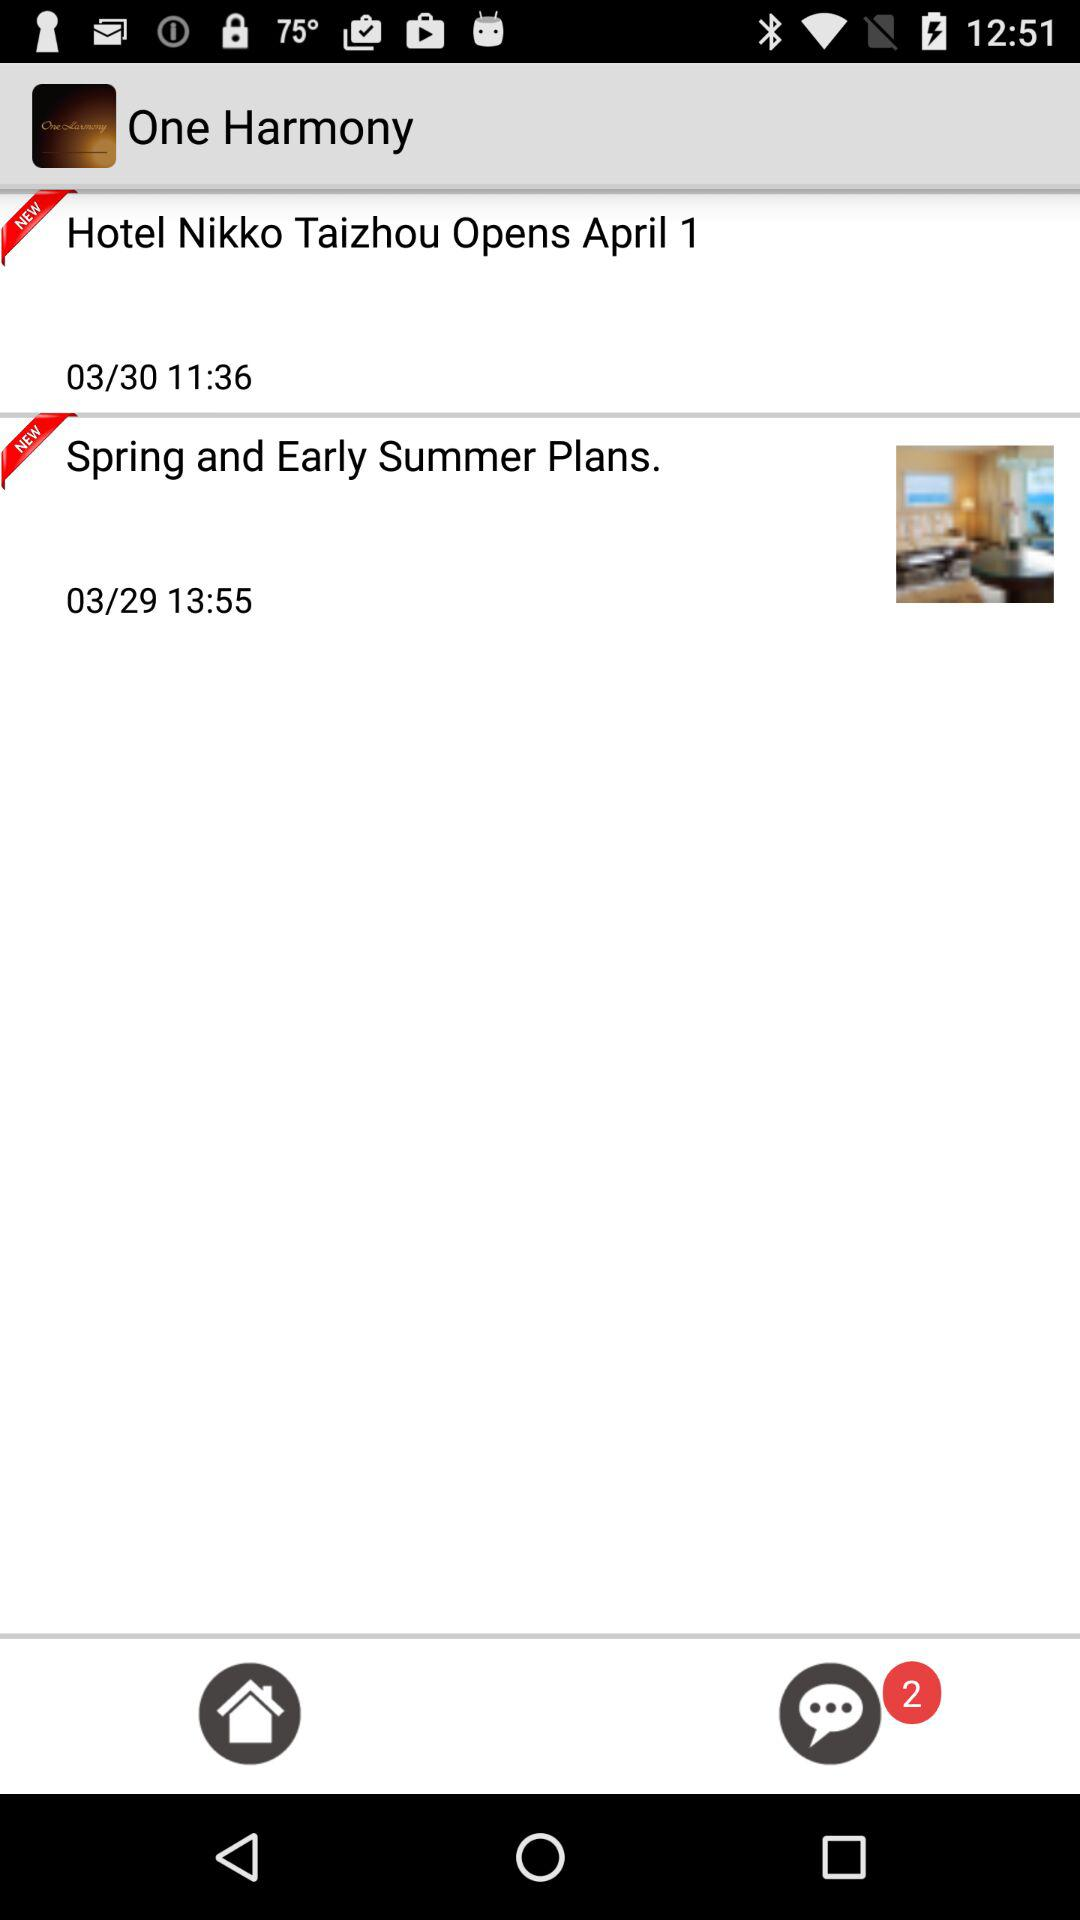How many notifications are there?
Answer the question using a single word or phrase. 2 